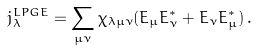<formula> <loc_0><loc_0><loc_500><loc_500>j ^ { L P G E } _ { \lambda } = \sum _ { \mu \nu } \chi _ { \lambda \mu \nu } ( E _ { \mu } E _ { \nu } ^ { * } + E _ { \nu } E _ { \mu } ^ { * } ) \, .</formula> 